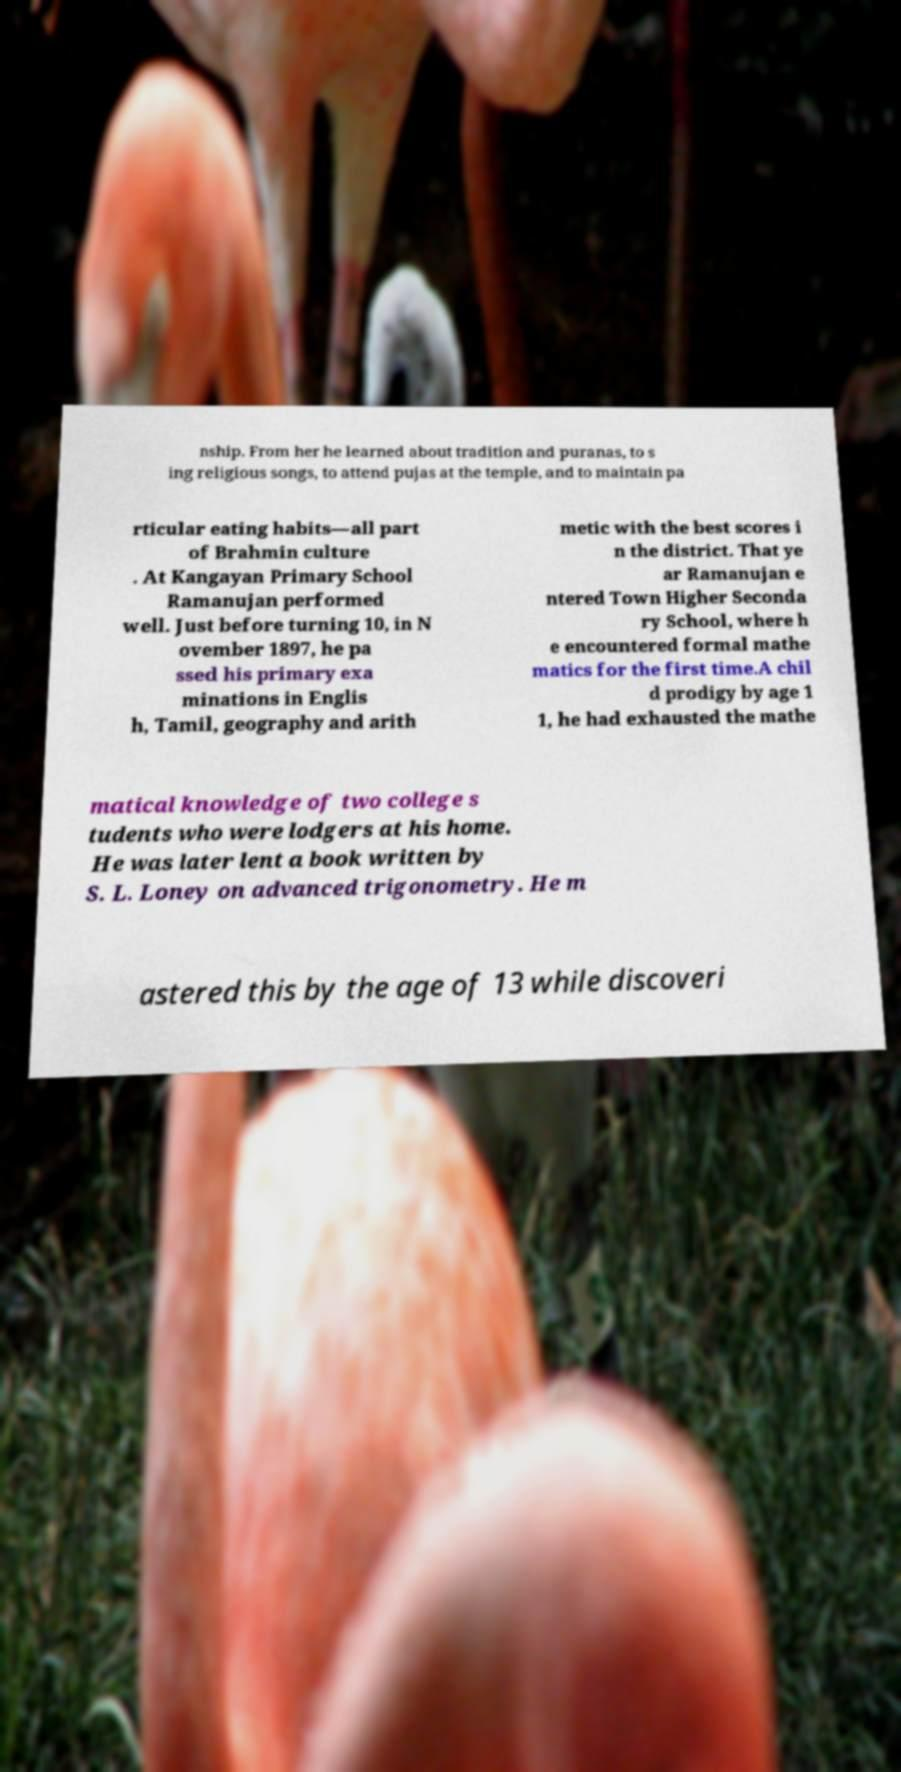Please read and relay the text visible in this image. What does it say? nship. From her he learned about tradition and puranas, to s ing religious songs, to attend pujas at the temple, and to maintain pa rticular eating habits—all part of Brahmin culture . At Kangayan Primary School Ramanujan performed well. Just before turning 10, in N ovember 1897, he pa ssed his primary exa minations in Englis h, Tamil, geography and arith metic with the best scores i n the district. That ye ar Ramanujan e ntered Town Higher Seconda ry School, where h e encountered formal mathe matics for the first time.A chil d prodigy by age 1 1, he had exhausted the mathe matical knowledge of two college s tudents who were lodgers at his home. He was later lent a book written by S. L. Loney on advanced trigonometry. He m astered this by the age of 13 while discoveri 